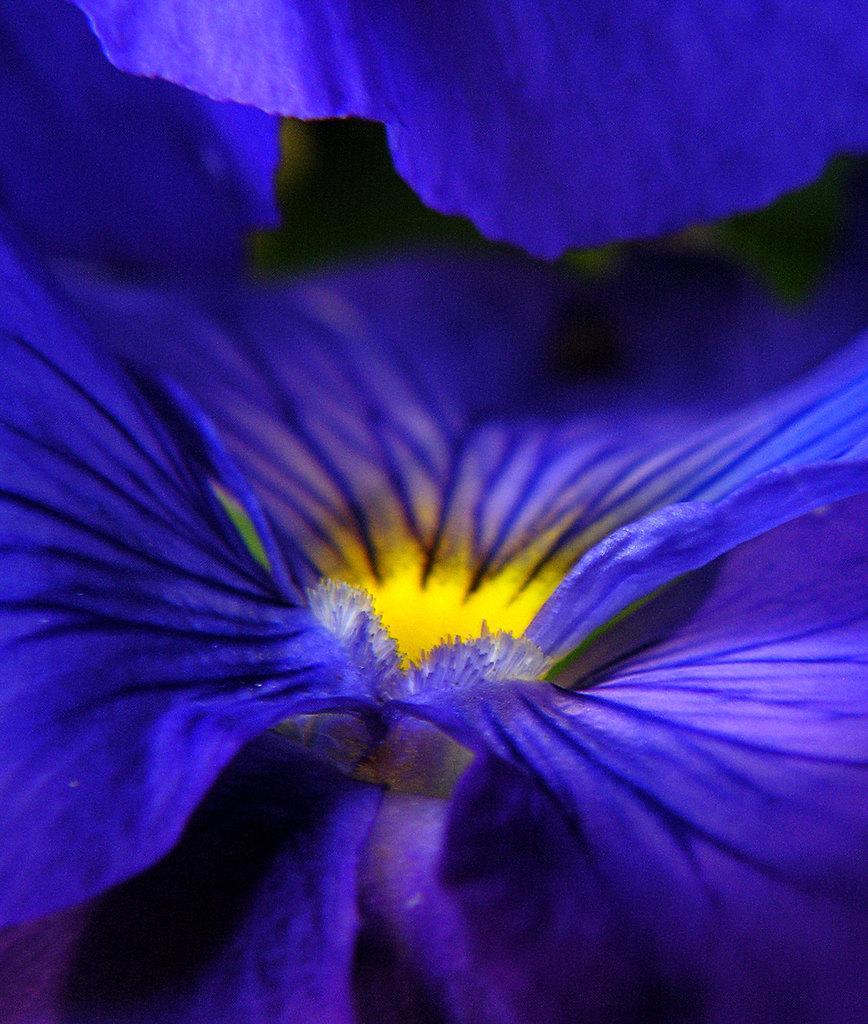How would you summarize this image in a sentence or two? In this image I can see a blue color flower. The background is in black color. 